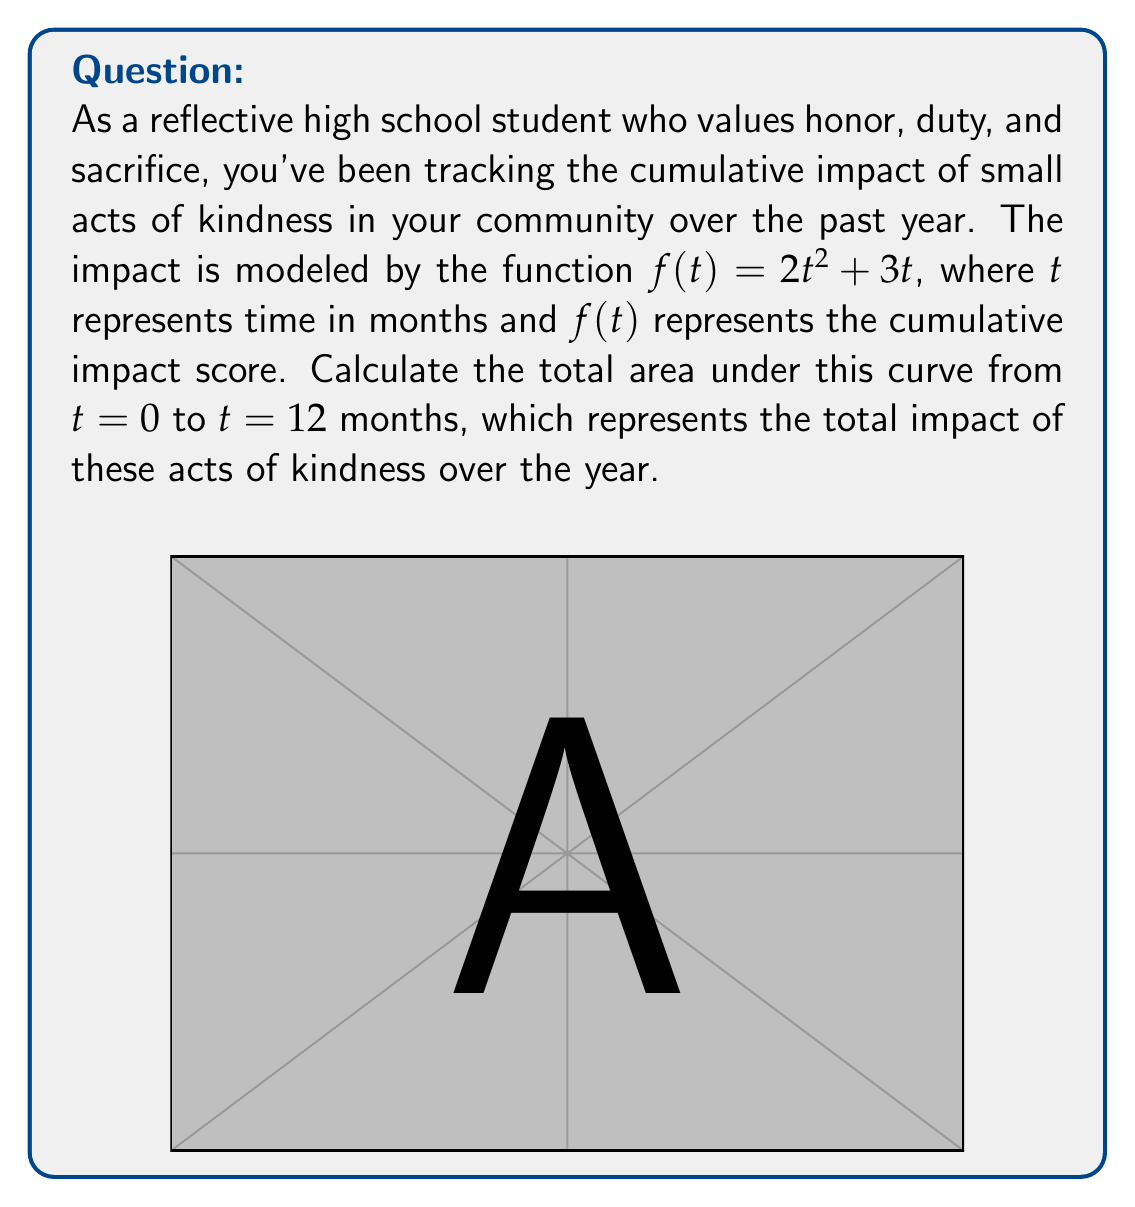Could you help me with this problem? To find the area under the curve, we need to calculate the definite integral of $f(t)$ from $t=0$ to $t=12$. Let's approach this step-by-step:

1) The function is $f(t) = 2t^2 + 3t$

2) We need to find $\int_0^{12} (2t^2 + 3t) dt$

3) Let's integrate each term separately:
   
   $\int 2t^2 dt = \frac{2t^3}{3} + C$
   
   $\int 3t dt = \frac{3t^2}{2} + C$

4) Combining these, we get:
   
   $\int (2t^2 + 3t) dt = \frac{2t^3}{3} + \frac{3t^2}{2} + C$

5) Now, we apply the fundamental theorem of calculus:

   $\int_0^{12} (2t^2 + 3t) dt = [\frac{2t^3}{3} + \frac{3t^2}{2}]_0^{12}$

6) Evaluate at the upper and lower bounds:

   $= (\frac{2(12)^3}{3} + \frac{3(12)^2}{2}) - (\frac{2(0)^3}{3} + \frac{3(0)^2}{2})$

   $= (384 + 216) - (0 + 0)$

   $= 600$

Therefore, the total area under the curve, representing the cumulative impact of small acts of kindness over the year, is 600 units.
Answer: The area under the curve from $t=0$ to $t=12$ is 600 impact units. 